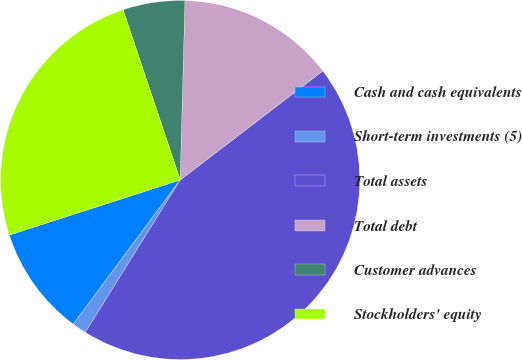Convert chart to OTSL. <chart><loc_0><loc_0><loc_500><loc_500><pie_chart><fcel>Cash and cash equivalents<fcel>Short-term investments (5)<fcel>Total assets<fcel>Total debt<fcel>Customer advances<fcel>Stockholders' equity<nl><fcel>9.88%<fcel>1.29%<fcel>44.26%<fcel>14.18%<fcel>5.58%<fcel>24.81%<nl></chart> 